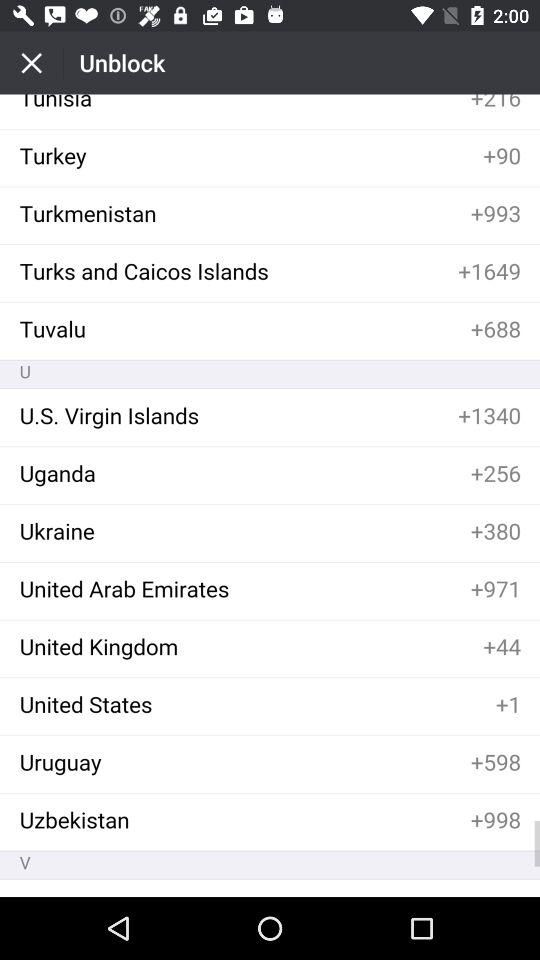What is the country code for Turkey? The country code for Turkey is +90. 